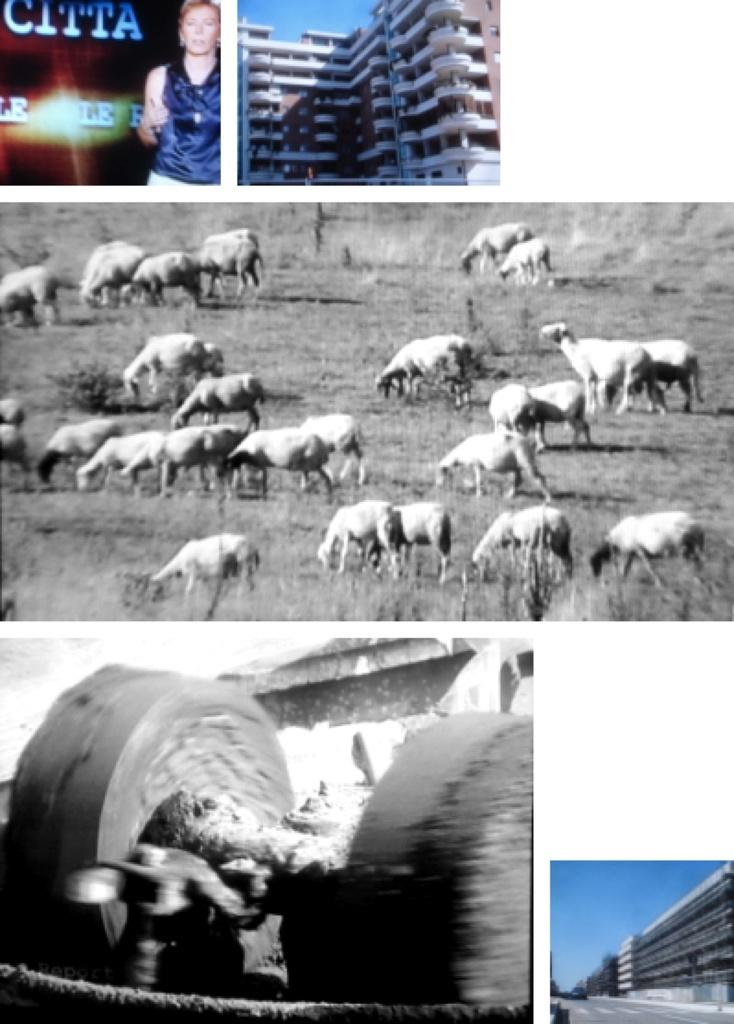What is the main subject of the image? The main subject of the image is a collage of buildings. Are there any living beings in the image? Yes, there is a person in the image. What other living creatures can be seen in the image? There are animals in the image. What is the weight of the trick in the morning in the image? There is no trick or mention of weight or morning in the image; it features a collage of buildings, a person, and animals. 